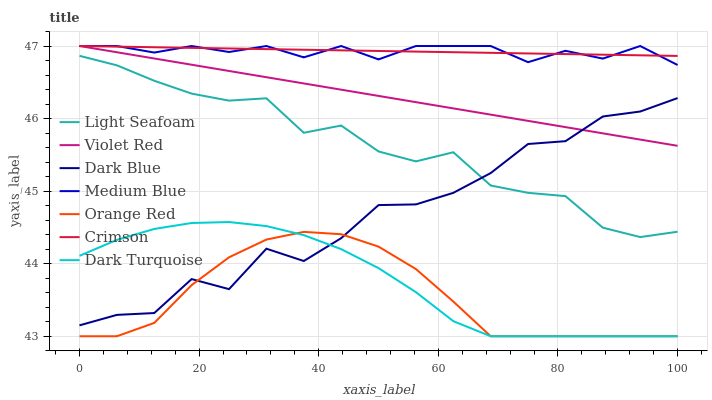Does Orange Red have the minimum area under the curve?
Answer yes or no. Yes. Does Crimson have the maximum area under the curve?
Answer yes or no. Yes. Does Dark Turquoise have the minimum area under the curve?
Answer yes or no. No. Does Dark Turquoise have the maximum area under the curve?
Answer yes or no. No. Is Violet Red the smoothest?
Answer yes or no. Yes. Is Dark Blue the roughest?
Answer yes or no. Yes. Is Dark Turquoise the smoothest?
Answer yes or no. No. Is Dark Turquoise the roughest?
Answer yes or no. No. Does Medium Blue have the lowest value?
Answer yes or no. No. Does Crimson have the highest value?
Answer yes or no. Yes. Does Dark Turquoise have the highest value?
Answer yes or no. No. Is Orange Red less than Medium Blue?
Answer yes or no. Yes. Is Crimson greater than Dark Turquoise?
Answer yes or no. Yes. Does Orange Red intersect Medium Blue?
Answer yes or no. No. 